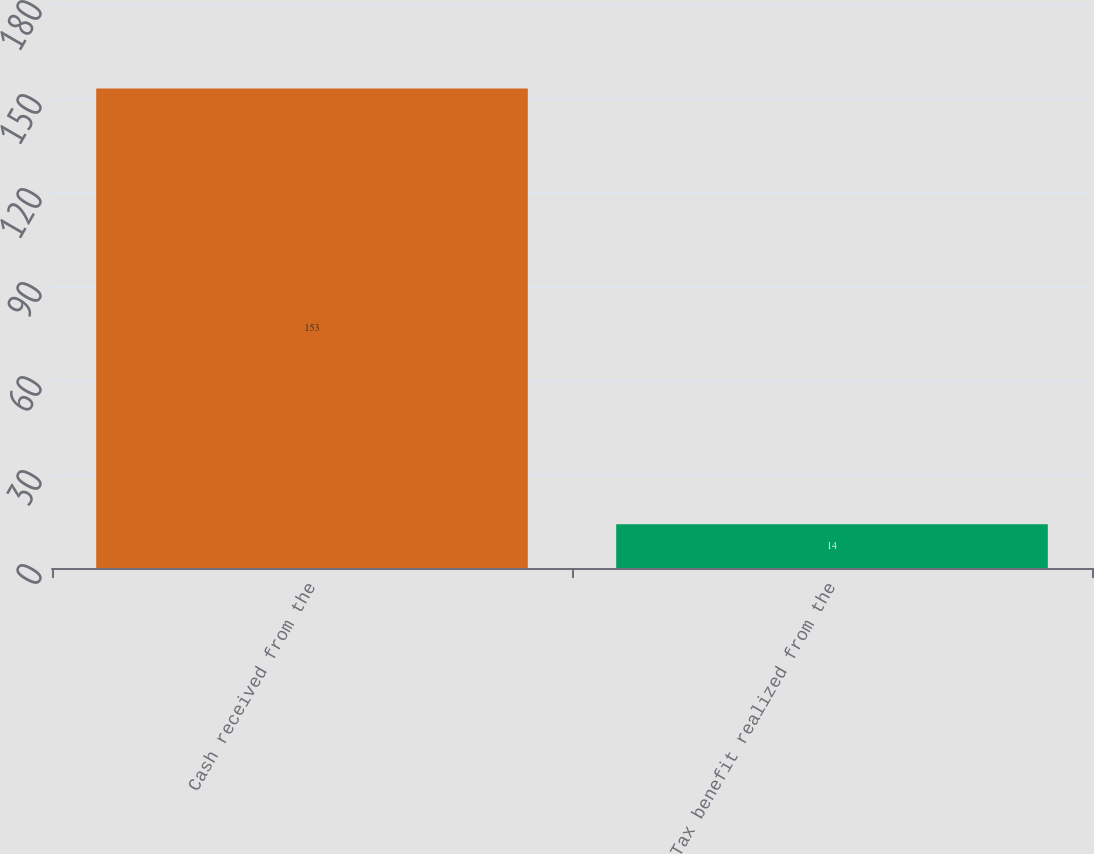Convert chart. <chart><loc_0><loc_0><loc_500><loc_500><bar_chart><fcel>Cash received from the<fcel>Tax benefit realized from the<nl><fcel>153<fcel>14<nl></chart> 